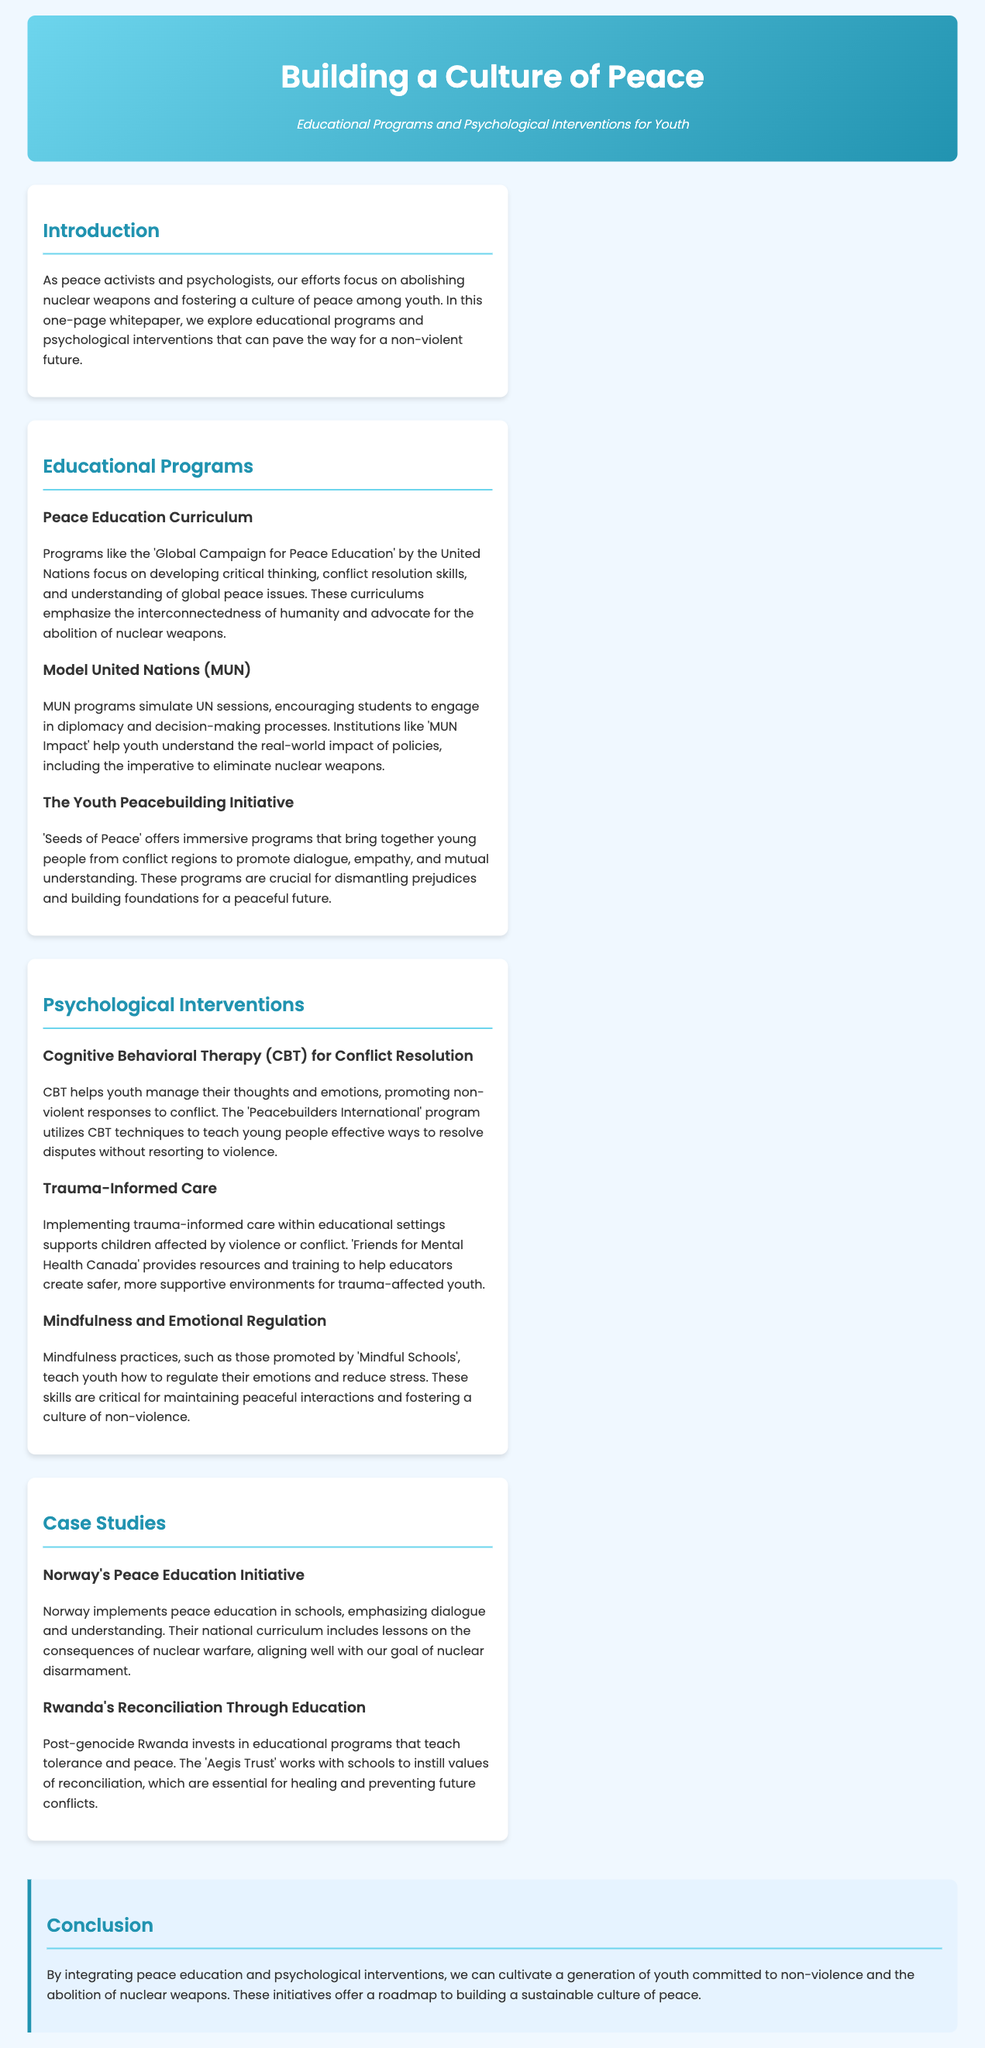what is the title of the whitepaper? The title of the whitepaper is prominently displayed at the top of the document.
Answer: Building a Culture of Peace who authored the 'Seeds of Peace' program? The 'Seeds of Peace' program is mentioned in the context of promoting dialogue and mutual understanding.
Answer: Seeds of Peace what psychological intervention is used for conflict resolution? The document lists specific psychological interventions that help with managing conflict.
Answer: Cognitive Behavioral Therapy (CBT) what does the 'Global Campaign for Peace Education' focus on? The document describes the objectives of various educational programs, including this one.
Answer: Developing critical thinking how does Norway’s initiative align with nuclear disarmament goals? The case study highlights specific educational components that relate to the overall theme of nuclear disarmament.
Answer: Consequences of nuclear warfare which organization trains educators to support trauma-affected youth? The document provides examples of organizations involved in fostering peace and supporting affected youth.
Answer: Friends for Mental Health Canada what is the essential theme cultivated by integrating peace education? The conclusion emphasizes the long-term goal of these educational initiatives.
Answer: Non-violence name a program that teaches mindfulness practices. The document includes references to programs specifically focused on mindfulness for youth.
Answer: Mindful Schools 